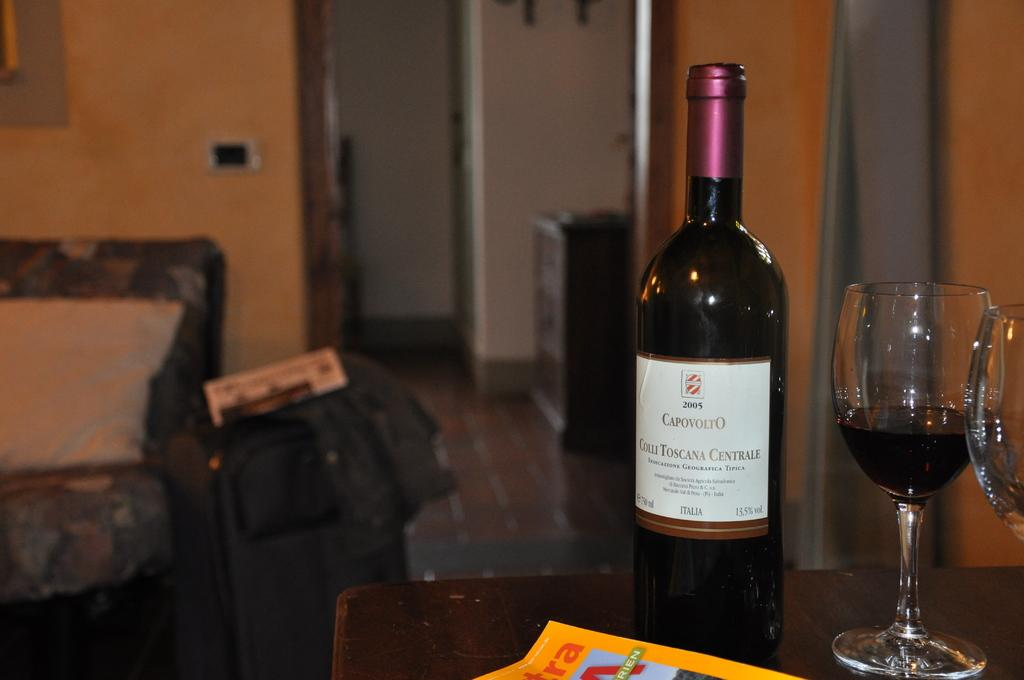<image>
Relay a brief, clear account of the picture shown. A bottle of Capovolto from 2005 sits on a table. 